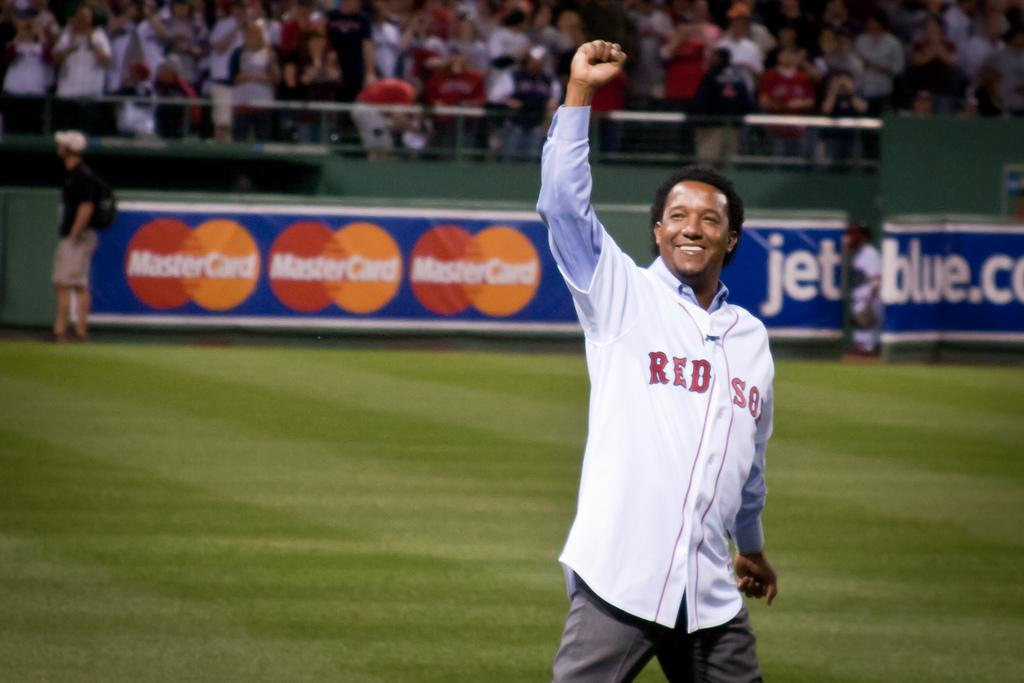<image>
Create a compact narrative representing the image presented. Red Sox Baseball Player on the field with billboard signs behind him saying Mastercard and Jetblue.com 